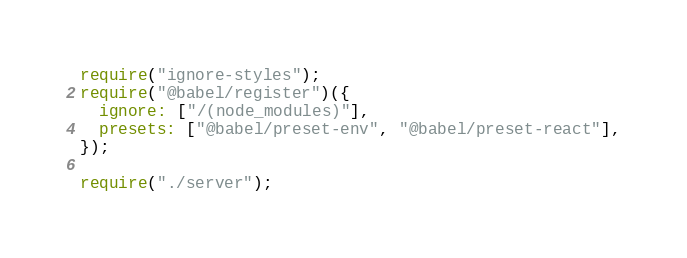Convert code to text. <code><loc_0><loc_0><loc_500><loc_500><_JavaScript_>require("ignore-styles");
require("@babel/register")({
  ignore: ["/(node_modules)"],
  presets: ["@babel/preset-env", "@babel/preset-react"],
});

require("./server");
</code> 